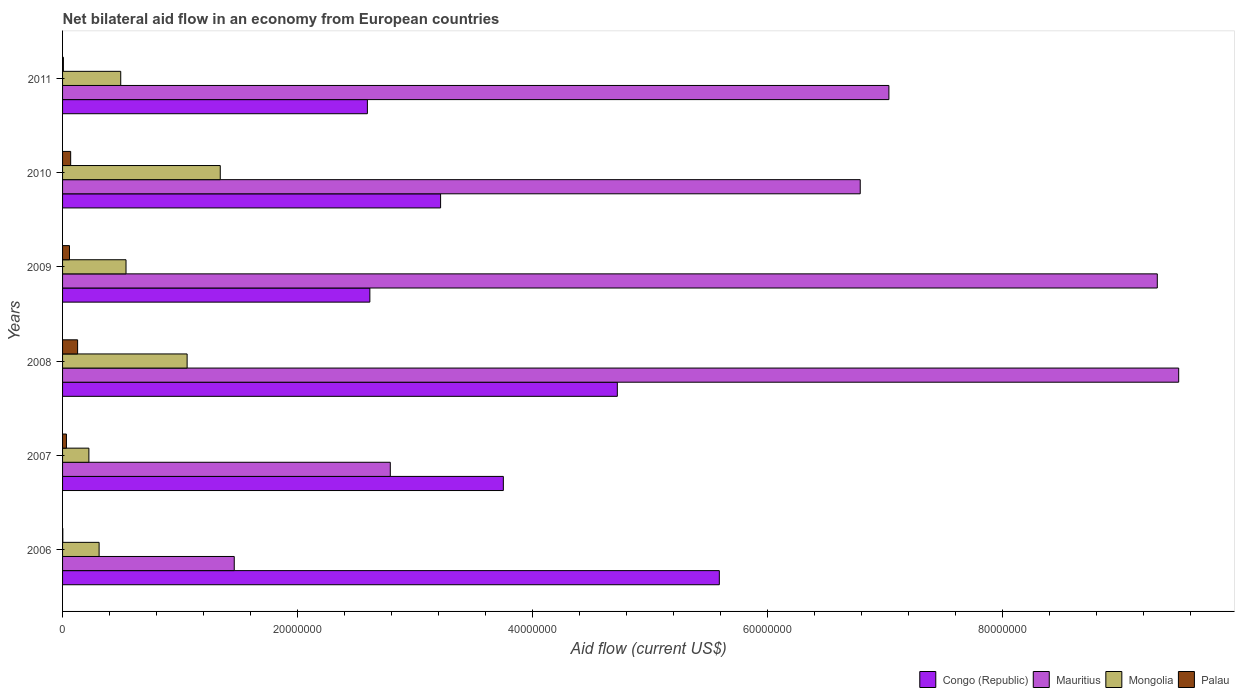How many different coloured bars are there?
Offer a very short reply. 4. How many groups of bars are there?
Your answer should be compact. 6. How many bars are there on the 6th tick from the bottom?
Make the answer very short. 4. What is the label of the 1st group of bars from the top?
Make the answer very short. 2011. What is the net bilateral aid flow in Mongolia in 2007?
Provide a succinct answer. 2.24e+06. Across all years, what is the maximum net bilateral aid flow in Palau?
Your response must be concise. 1.28e+06. In which year was the net bilateral aid flow in Congo (Republic) maximum?
Give a very brief answer. 2006. What is the total net bilateral aid flow in Palau in the graph?
Make the answer very short. 2.98e+06. What is the difference between the net bilateral aid flow in Palau in 2007 and that in 2008?
Your answer should be compact. -9.50e+05. What is the difference between the net bilateral aid flow in Mongolia in 2006 and the net bilateral aid flow in Palau in 2008?
Make the answer very short. 1.83e+06. What is the average net bilateral aid flow in Mauritius per year?
Your answer should be compact. 6.15e+07. In the year 2006, what is the difference between the net bilateral aid flow in Mauritius and net bilateral aid flow in Congo (Republic)?
Ensure brevity in your answer.  -4.13e+07. What is the ratio of the net bilateral aid flow in Congo (Republic) in 2008 to that in 2010?
Make the answer very short. 1.47. Is the difference between the net bilateral aid flow in Mauritius in 2006 and 2009 greater than the difference between the net bilateral aid flow in Congo (Republic) in 2006 and 2009?
Offer a terse response. No. What is the difference between the highest and the second highest net bilateral aid flow in Mauritius?
Offer a terse response. 1.82e+06. What is the difference between the highest and the lowest net bilateral aid flow in Congo (Republic)?
Offer a very short reply. 3.00e+07. Is the sum of the net bilateral aid flow in Palau in 2008 and 2009 greater than the maximum net bilateral aid flow in Congo (Republic) across all years?
Keep it short and to the point. No. What does the 2nd bar from the top in 2006 represents?
Ensure brevity in your answer.  Mongolia. What does the 2nd bar from the bottom in 2009 represents?
Keep it short and to the point. Mauritius. How many bars are there?
Provide a succinct answer. 24. Are all the bars in the graph horizontal?
Keep it short and to the point. Yes. How many years are there in the graph?
Offer a terse response. 6. What is the difference between two consecutive major ticks on the X-axis?
Ensure brevity in your answer.  2.00e+07. Does the graph contain any zero values?
Provide a succinct answer. No. Does the graph contain grids?
Your answer should be compact. No. How many legend labels are there?
Give a very brief answer. 4. What is the title of the graph?
Give a very brief answer. Net bilateral aid flow in an economy from European countries. What is the label or title of the Y-axis?
Provide a short and direct response. Years. What is the Aid flow (current US$) of Congo (Republic) in 2006?
Ensure brevity in your answer.  5.59e+07. What is the Aid flow (current US$) in Mauritius in 2006?
Offer a terse response. 1.46e+07. What is the Aid flow (current US$) of Mongolia in 2006?
Offer a terse response. 3.11e+06. What is the Aid flow (current US$) of Congo (Republic) in 2007?
Keep it short and to the point. 3.75e+07. What is the Aid flow (current US$) in Mauritius in 2007?
Your answer should be compact. 2.79e+07. What is the Aid flow (current US$) of Mongolia in 2007?
Offer a terse response. 2.24e+06. What is the Aid flow (current US$) in Palau in 2007?
Make the answer very short. 3.30e+05. What is the Aid flow (current US$) of Congo (Republic) in 2008?
Offer a terse response. 4.72e+07. What is the Aid flow (current US$) in Mauritius in 2008?
Ensure brevity in your answer.  9.50e+07. What is the Aid flow (current US$) of Mongolia in 2008?
Your response must be concise. 1.06e+07. What is the Aid flow (current US$) of Palau in 2008?
Keep it short and to the point. 1.28e+06. What is the Aid flow (current US$) in Congo (Republic) in 2009?
Ensure brevity in your answer.  2.62e+07. What is the Aid flow (current US$) of Mauritius in 2009?
Ensure brevity in your answer.  9.32e+07. What is the Aid flow (current US$) of Mongolia in 2009?
Give a very brief answer. 5.40e+06. What is the Aid flow (current US$) of Palau in 2009?
Your answer should be very brief. 5.90e+05. What is the Aid flow (current US$) of Congo (Republic) in 2010?
Give a very brief answer. 3.22e+07. What is the Aid flow (current US$) in Mauritius in 2010?
Give a very brief answer. 6.79e+07. What is the Aid flow (current US$) of Mongolia in 2010?
Provide a succinct answer. 1.34e+07. What is the Aid flow (current US$) of Palau in 2010?
Ensure brevity in your answer.  6.90e+05. What is the Aid flow (current US$) of Congo (Republic) in 2011?
Ensure brevity in your answer.  2.59e+07. What is the Aid flow (current US$) of Mauritius in 2011?
Make the answer very short. 7.03e+07. What is the Aid flow (current US$) in Mongolia in 2011?
Provide a succinct answer. 4.95e+06. Across all years, what is the maximum Aid flow (current US$) of Congo (Republic)?
Provide a succinct answer. 5.59e+07. Across all years, what is the maximum Aid flow (current US$) of Mauritius?
Your answer should be compact. 9.50e+07. Across all years, what is the maximum Aid flow (current US$) of Mongolia?
Offer a terse response. 1.34e+07. Across all years, what is the maximum Aid flow (current US$) in Palau?
Provide a succinct answer. 1.28e+06. Across all years, what is the minimum Aid flow (current US$) of Congo (Republic)?
Give a very brief answer. 2.59e+07. Across all years, what is the minimum Aid flow (current US$) in Mauritius?
Your answer should be compact. 1.46e+07. Across all years, what is the minimum Aid flow (current US$) of Mongolia?
Your answer should be very brief. 2.24e+06. What is the total Aid flow (current US$) of Congo (Republic) in the graph?
Give a very brief answer. 2.25e+08. What is the total Aid flow (current US$) of Mauritius in the graph?
Offer a very short reply. 3.69e+08. What is the total Aid flow (current US$) in Mongolia in the graph?
Give a very brief answer. 3.97e+07. What is the total Aid flow (current US$) in Palau in the graph?
Make the answer very short. 2.98e+06. What is the difference between the Aid flow (current US$) in Congo (Republic) in 2006 and that in 2007?
Make the answer very short. 1.84e+07. What is the difference between the Aid flow (current US$) in Mauritius in 2006 and that in 2007?
Your answer should be compact. -1.33e+07. What is the difference between the Aid flow (current US$) in Mongolia in 2006 and that in 2007?
Provide a short and direct response. 8.70e+05. What is the difference between the Aid flow (current US$) of Palau in 2006 and that in 2007?
Offer a terse response. -3.10e+05. What is the difference between the Aid flow (current US$) in Congo (Republic) in 2006 and that in 2008?
Provide a succinct answer. 8.68e+06. What is the difference between the Aid flow (current US$) in Mauritius in 2006 and that in 2008?
Give a very brief answer. -8.04e+07. What is the difference between the Aid flow (current US$) in Mongolia in 2006 and that in 2008?
Offer a very short reply. -7.49e+06. What is the difference between the Aid flow (current US$) in Palau in 2006 and that in 2008?
Offer a very short reply. -1.26e+06. What is the difference between the Aid flow (current US$) in Congo (Republic) in 2006 and that in 2009?
Provide a short and direct response. 2.97e+07. What is the difference between the Aid flow (current US$) in Mauritius in 2006 and that in 2009?
Provide a succinct answer. -7.86e+07. What is the difference between the Aid flow (current US$) in Mongolia in 2006 and that in 2009?
Give a very brief answer. -2.29e+06. What is the difference between the Aid flow (current US$) of Palau in 2006 and that in 2009?
Your answer should be very brief. -5.70e+05. What is the difference between the Aid flow (current US$) in Congo (Republic) in 2006 and that in 2010?
Provide a short and direct response. 2.37e+07. What is the difference between the Aid flow (current US$) in Mauritius in 2006 and that in 2010?
Ensure brevity in your answer.  -5.33e+07. What is the difference between the Aid flow (current US$) in Mongolia in 2006 and that in 2010?
Offer a very short reply. -1.03e+07. What is the difference between the Aid flow (current US$) in Palau in 2006 and that in 2010?
Provide a succinct answer. -6.70e+05. What is the difference between the Aid flow (current US$) in Congo (Republic) in 2006 and that in 2011?
Keep it short and to the point. 3.00e+07. What is the difference between the Aid flow (current US$) of Mauritius in 2006 and that in 2011?
Your answer should be compact. -5.57e+07. What is the difference between the Aid flow (current US$) in Mongolia in 2006 and that in 2011?
Ensure brevity in your answer.  -1.84e+06. What is the difference between the Aid flow (current US$) of Palau in 2006 and that in 2011?
Keep it short and to the point. -5.00e+04. What is the difference between the Aid flow (current US$) in Congo (Republic) in 2007 and that in 2008?
Offer a terse response. -9.70e+06. What is the difference between the Aid flow (current US$) of Mauritius in 2007 and that in 2008?
Your answer should be compact. -6.71e+07. What is the difference between the Aid flow (current US$) of Mongolia in 2007 and that in 2008?
Ensure brevity in your answer.  -8.36e+06. What is the difference between the Aid flow (current US$) of Palau in 2007 and that in 2008?
Offer a terse response. -9.50e+05. What is the difference between the Aid flow (current US$) of Congo (Republic) in 2007 and that in 2009?
Ensure brevity in your answer.  1.14e+07. What is the difference between the Aid flow (current US$) in Mauritius in 2007 and that in 2009?
Provide a succinct answer. -6.53e+07. What is the difference between the Aid flow (current US$) in Mongolia in 2007 and that in 2009?
Offer a terse response. -3.16e+06. What is the difference between the Aid flow (current US$) in Congo (Republic) in 2007 and that in 2010?
Your response must be concise. 5.34e+06. What is the difference between the Aid flow (current US$) of Mauritius in 2007 and that in 2010?
Your answer should be very brief. -4.00e+07. What is the difference between the Aid flow (current US$) of Mongolia in 2007 and that in 2010?
Your answer should be compact. -1.12e+07. What is the difference between the Aid flow (current US$) of Palau in 2007 and that in 2010?
Provide a short and direct response. -3.60e+05. What is the difference between the Aid flow (current US$) in Congo (Republic) in 2007 and that in 2011?
Make the answer very short. 1.16e+07. What is the difference between the Aid flow (current US$) in Mauritius in 2007 and that in 2011?
Provide a succinct answer. -4.24e+07. What is the difference between the Aid flow (current US$) in Mongolia in 2007 and that in 2011?
Your answer should be compact. -2.71e+06. What is the difference between the Aid flow (current US$) of Congo (Republic) in 2008 and that in 2009?
Keep it short and to the point. 2.11e+07. What is the difference between the Aid flow (current US$) in Mauritius in 2008 and that in 2009?
Give a very brief answer. 1.82e+06. What is the difference between the Aid flow (current US$) in Mongolia in 2008 and that in 2009?
Ensure brevity in your answer.  5.20e+06. What is the difference between the Aid flow (current US$) in Palau in 2008 and that in 2009?
Your answer should be compact. 6.90e+05. What is the difference between the Aid flow (current US$) of Congo (Republic) in 2008 and that in 2010?
Give a very brief answer. 1.50e+07. What is the difference between the Aid flow (current US$) of Mauritius in 2008 and that in 2010?
Ensure brevity in your answer.  2.71e+07. What is the difference between the Aid flow (current US$) of Mongolia in 2008 and that in 2010?
Provide a succinct answer. -2.82e+06. What is the difference between the Aid flow (current US$) of Palau in 2008 and that in 2010?
Your answer should be very brief. 5.90e+05. What is the difference between the Aid flow (current US$) of Congo (Republic) in 2008 and that in 2011?
Offer a very short reply. 2.13e+07. What is the difference between the Aid flow (current US$) in Mauritius in 2008 and that in 2011?
Your answer should be compact. 2.47e+07. What is the difference between the Aid flow (current US$) in Mongolia in 2008 and that in 2011?
Make the answer very short. 5.65e+06. What is the difference between the Aid flow (current US$) in Palau in 2008 and that in 2011?
Give a very brief answer. 1.21e+06. What is the difference between the Aid flow (current US$) in Congo (Republic) in 2009 and that in 2010?
Ensure brevity in your answer.  -6.02e+06. What is the difference between the Aid flow (current US$) of Mauritius in 2009 and that in 2010?
Keep it short and to the point. 2.53e+07. What is the difference between the Aid flow (current US$) in Mongolia in 2009 and that in 2010?
Offer a very short reply. -8.02e+06. What is the difference between the Aid flow (current US$) of Palau in 2009 and that in 2010?
Offer a very short reply. -1.00e+05. What is the difference between the Aid flow (current US$) in Mauritius in 2009 and that in 2011?
Give a very brief answer. 2.28e+07. What is the difference between the Aid flow (current US$) in Palau in 2009 and that in 2011?
Provide a succinct answer. 5.20e+05. What is the difference between the Aid flow (current US$) in Congo (Republic) in 2010 and that in 2011?
Give a very brief answer. 6.23e+06. What is the difference between the Aid flow (current US$) of Mauritius in 2010 and that in 2011?
Provide a short and direct response. -2.44e+06. What is the difference between the Aid flow (current US$) of Mongolia in 2010 and that in 2011?
Offer a very short reply. 8.47e+06. What is the difference between the Aid flow (current US$) in Palau in 2010 and that in 2011?
Offer a terse response. 6.20e+05. What is the difference between the Aid flow (current US$) in Congo (Republic) in 2006 and the Aid flow (current US$) in Mauritius in 2007?
Offer a terse response. 2.80e+07. What is the difference between the Aid flow (current US$) of Congo (Republic) in 2006 and the Aid flow (current US$) of Mongolia in 2007?
Give a very brief answer. 5.36e+07. What is the difference between the Aid flow (current US$) in Congo (Republic) in 2006 and the Aid flow (current US$) in Palau in 2007?
Your response must be concise. 5.56e+07. What is the difference between the Aid flow (current US$) of Mauritius in 2006 and the Aid flow (current US$) of Mongolia in 2007?
Your answer should be very brief. 1.24e+07. What is the difference between the Aid flow (current US$) of Mauritius in 2006 and the Aid flow (current US$) of Palau in 2007?
Keep it short and to the point. 1.43e+07. What is the difference between the Aid flow (current US$) of Mongolia in 2006 and the Aid flow (current US$) of Palau in 2007?
Provide a succinct answer. 2.78e+06. What is the difference between the Aid flow (current US$) in Congo (Republic) in 2006 and the Aid flow (current US$) in Mauritius in 2008?
Offer a terse response. -3.91e+07. What is the difference between the Aid flow (current US$) in Congo (Republic) in 2006 and the Aid flow (current US$) in Mongolia in 2008?
Your answer should be very brief. 4.53e+07. What is the difference between the Aid flow (current US$) in Congo (Republic) in 2006 and the Aid flow (current US$) in Palau in 2008?
Ensure brevity in your answer.  5.46e+07. What is the difference between the Aid flow (current US$) of Mauritius in 2006 and the Aid flow (current US$) of Mongolia in 2008?
Provide a succinct answer. 4.01e+06. What is the difference between the Aid flow (current US$) in Mauritius in 2006 and the Aid flow (current US$) in Palau in 2008?
Your answer should be very brief. 1.33e+07. What is the difference between the Aid flow (current US$) in Mongolia in 2006 and the Aid flow (current US$) in Palau in 2008?
Your answer should be compact. 1.83e+06. What is the difference between the Aid flow (current US$) of Congo (Republic) in 2006 and the Aid flow (current US$) of Mauritius in 2009?
Offer a very short reply. -3.73e+07. What is the difference between the Aid flow (current US$) of Congo (Republic) in 2006 and the Aid flow (current US$) of Mongolia in 2009?
Give a very brief answer. 5.05e+07. What is the difference between the Aid flow (current US$) in Congo (Republic) in 2006 and the Aid flow (current US$) in Palau in 2009?
Ensure brevity in your answer.  5.53e+07. What is the difference between the Aid flow (current US$) in Mauritius in 2006 and the Aid flow (current US$) in Mongolia in 2009?
Give a very brief answer. 9.21e+06. What is the difference between the Aid flow (current US$) in Mauritius in 2006 and the Aid flow (current US$) in Palau in 2009?
Offer a terse response. 1.40e+07. What is the difference between the Aid flow (current US$) of Mongolia in 2006 and the Aid flow (current US$) of Palau in 2009?
Your answer should be very brief. 2.52e+06. What is the difference between the Aid flow (current US$) of Congo (Republic) in 2006 and the Aid flow (current US$) of Mauritius in 2010?
Keep it short and to the point. -1.20e+07. What is the difference between the Aid flow (current US$) of Congo (Republic) in 2006 and the Aid flow (current US$) of Mongolia in 2010?
Give a very brief answer. 4.25e+07. What is the difference between the Aid flow (current US$) in Congo (Republic) in 2006 and the Aid flow (current US$) in Palau in 2010?
Provide a short and direct response. 5.52e+07. What is the difference between the Aid flow (current US$) of Mauritius in 2006 and the Aid flow (current US$) of Mongolia in 2010?
Give a very brief answer. 1.19e+06. What is the difference between the Aid flow (current US$) in Mauritius in 2006 and the Aid flow (current US$) in Palau in 2010?
Ensure brevity in your answer.  1.39e+07. What is the difference between the Aid flow (current US$) of Mongolia in 2006 and the Aid flow (current US$) of Palau in 2010?
Make the answer very short. 2.42e+06. What is the difference between the Aid flow (current US$) of Congo (Republic) in 2006 and the Aid flow (current US$) of Mauritius in 2011?
Offer a terse response. -1.44e+07. What is the difference between the Aid flow (current US$) in Congo (Republic) in 2006 and the Aid flow (current US$) in Mongolia in 2011?
Your answer should be very brief. 5.09e+07. What is the difference between the Aid flow (current US$) in Congo (Republic) in 2006 and the Aid flow (current US$) in Palau in 2011?
Provide a short and direct response. 5.58e+07. What is the difference between the Aid flow (current US$) of Mauritius in 2006 and the Aid flow (current US$) of Mongolia in 2011?
Offer a terse response. 9.66e+06. What is the difference between the Aid flow (current US$) of Mauritius in 2006 and the Aid flow (current US$) of Palau in 2011?
Provide a succinct answer. 1.45e+07. What is the difference between the Aid flow (current US$) of Mongolia in 2006 and the Aid flow (current US$) of Palau in 2011?
Make the answer very short. 3.04e+06. What is the difference between the Aid flow (current US$) of Congo (Republic) in 2007 and the Aid flow (current US$) of Mauritius in 2008?
Provide a short and direct response. -5.75e+07. What is the difference between the Aid flow (current US$) in Congo (Republic) in 2007 and the Aid flow (current US$) in Mongolia in 2008?
Offer a very short reply. 2.69e+07. What is the difference between the Aid flow (current US$) in Congo (Republic) in 2007 and the Aid flow (current US$) in Palau in 2008?
Make the answer very short. 3.62e+07. What is the difference between the Aid flow (current US$) in Mauritius in 2007 and the Aid flow (current US$) in Mongolia in 2008?
Provide a short and direct response. 1.73e+07. What is the difference between the Aid flow (current US$) in Mauritius in 2007 and the Aid flow (current US$) in Palau in 2008?
Offer a very short reply. 2.66e+07. What is the difference between the Aid flow (current US$) of Mongolia in 2007 and the Aid flow (current US$) of Palau in 2008?
Your answer should be compact. 9.60e+05. What is the difference between the Aid flow (current US$) in Congo (Republic) in 2007 and the Aid flow (current US$) in Mauritius in 2009?
Provide a succinct answer. -5.56e+07. What is the difference between the Aid flow (current US$) of Congo (Republic) in 2007 and the Aid flow (current US$) of Mongolia in 2009?
Your response must be concise. 3.21e+07. What is the difference between the Aid flow (current US$) of Congo (Republic) in 2007 and the Aid flow (current US$) of Palau in 2009?
Provide a succinct answer. 3.69e+07. What is the difference between the Aid flow (current US$) of Mauritius in 2007 and the Aid flow (current US$) of Mongolia in 2009?
Make the answer very short. 2.25e+07. What is the difference between the Aid flow (current US$) of Mauritius in 2007 and the Aid flow (current US$) of Palau in 2009?
Offer a very short reply. 2.73e+07. What is the difference between the Aid flow (current US$) of Mongolia in 2007 and the Aid flow (current US$) of Palau in 2009?
Offer a very short reply. 1.65e+06. What is the difference between the Aid flow (current US$) of Congo (Republic) in 2007 and the Aid flow (current US$) of Mauritius in 2010?
Your response must be concise. -3.04e+07. What is the difference between the Aid flow (current US$) in Congo (Republic) in 2007 and the Aid flow (current US$) in Mongolia in 2010?
Your answer should be very brief. 2.41e+07. What is the difference between the Aid flow (current US$) in Congo (Republic) in 2007 and the Aid flow (current US$) in Palau in 2010?
Make the answer very short. 3.68e+07. What is the difference between the Aid flow (current US$) of Mauritius in 2007 and the Aid flow (current US$) of Mongolia in 2010?
Provide a succinct answer. 1.45e+07. What is the difference between the Aid flow (current US$) in Mauritius in 2007 and the Aid flow (current US$) in Palau in 2010?
Keep it short and to the point. 2.72e+07. What is the difference between the Aid flow (current US$) of Mongolia in 2007 and the Aid flow (current US$) of Palau in 2010?
Your answer should be very brief. 1.55e+06. What is the difference between the Aid flow (current US$) of Congo (Republic) in 2007 and the Aid flow (current US$) of Mauritius in 2011?
Offer a very short reply. -3.28e+07. What is the difference between the Aid flow (current US$) in Congo (Republic) in 2007 and the Aid flow (current US$) in Mongolia in 2011?
Make the answer very short. 3.26e+07. What is the difference between the Aid flow (current US$) of Congo (Republic) in 2007 and the Aid flow (current US$) of Palau in 2011?
Offer a very short reply. 3.74e+07. What is the difference between the Aid flow (current US$) of Mauritius in 2007 and the Aid flow (current US$) of Mongolia in 2011?
Offer a very short reply. 2.29e+07. What is the difference between the Aid flow (current US$) in Mauritius in 2007 and the Aid flow (current US$) in Palau in 2011?
Your response must be concise. 2.78e+07. What is the difference between the Aid flow (current US$) of Mongolia in 2007 and the Aid flow (current US$) of Palau in 2011?
Offer a very short reply. 2.17e+06. What is the difference between the Aid flow (current US$) in Congo (Republic) in 2008 and the Aid flow (current US$) in Mauritius in 2009?
Keep it short and to the point. -4.60e+07. What is the difference between the Aid flow (current US$) of Congo (Republic) in 2008 and the Aid flow (current US$) of Mongolia in 2009?
Provide a succinct answer. 4.18e+07. What is the difference between the Aid flow (current US$) in Congo (Republic) in 2008 and the Aid flow (current US$) in Palau in 2009?
Keep it short and to the point. 4.66e+07. What is the difference between the Aid flow (current US$) of Mauritius in 2008 and the Aid flow (current US$) of Mongolia in 2009?
Make the answer very short. 8.96e+07. What is the difference between the Aid flow (current US$) of Mauritius in 2008 and the Aid flow (current US$) of Palau in 2009?
Your answer should be very brief. 9.44e+07. What is the difference between the Aid flow (current US$) in Mongolia in 2008 and the Aid flow (current US$) in Palau in 2009?
Provide a short and direct response. 1.00e+07. What is the difference between the Aid flow (current US$) in Congo (Republic) in 2008 and the Aid flow (current US$) in Mauritius in 2010?
Provide a short and direct response. -2.07e+07. What is the difference between the Aid flow (current US$) in Congo (Republic) in 2008 and the Aid flow (current US$) in Mongolia in 2010?
Your answer should be compact. 3.38e+07. What is the difference between the Aid flow (current US$) in Congo (Republic) in 2008 and the Aid flow (current US$) in Palau in 2010?
Provide a short and direct response. 4.65e+07. What is the difference between the Aid flow (current US$) in Mauritius in 2008 and the Aid flow (current US$) in Mongolia in 2010?
Give a very brief answer. 8.16e+07. What is the difference between the Aid flow (current US$) of Mauritius in 2008 and the Aid flow (current US$) of Palau in 2010?
Provide a short and direct response. 9.43e+07. What is the difference between the Aid flow (current US$) of Mongolia in 2008 and the Aid flow (current US$) of Palau in 2010?
Provide a succinct answer. 9.91e+06. What is the difference between the Aid flow (current US$) in Congo (Republic) in 2008 and the Aid flow (current US$) in Mauritius in 2011?
Offer a very short reply. -2.31e+07. What is the difference between the Aid flow (current US$) of Congo (Republic) in 2008 and the Aid flow (current US$) of Mongolia in 2011?
Provide a succinct answer. 4.23e+07. What is the difference between the Aid flow (current US$) of Congo (Republic) in 2008 and the Aid flow (current US$) of Palau in 2011?
Ensure brevity in your answer.  4.71e+07. What is the difference between the Aid flow (current US$) of Mauritius in 2008 and the Aid flow (current US$) of Mongolia in 2011?
Keep it short and to the point. 9.00e+07. What is the difference between the Aid flow (current US$) in Mauritius in 2008 and the Aid flow (current US$) in Palau in 2011?
Ensure brevity in your answer.  9.49e+07. What is the difference between the Aid flow (current US$) in Mongolia in 2008 and the Aid flow (current US$) in Palau in 2011?
Provide a short and direct response. 1.05e+07. What is the difference between the Aid flow (current US$) in Congo (Republic) in 2009 and the Aid flow (current US$) in Mauritius in 2010?
Your answer should be very brief. -4.17e+07. What is the difference between the Aid flow (current US$) of Congo (Republic) in 2009 and the Aid flow (current US$) of Mongolia in 2010?
Your answer should be compact. 1.27e+07. What is the difference between the Aid flow (current US$) of Congo (Republic) in 2009 and the Aid flow (current US$) of Palau in 2010?
Your answer should be very brief. 2.55e+07. What is the difference between the Aid flow (current US$) of Mauritius in 2009 and the Aid flow (current US$) of Mongolia in 2010?
Give a very brief answer. 7.97e+07. What is the difference between the Aid flow (current US$) in Mauritius in 2009 and the Aid flow (current US$) in Palau in 2010?
Make the answer very short. 9.25e+07. What is the difference between the Aid flow (current US$) in Mongolia in 2009 and the Aid flow (current US$) in Palau in 2010?
Give a very brief answer. 4.71e+06. What is the difference between the Aid flow (current US$) in Congo (Republic) in 2009 and the Aid flow (current US$) in Mauritius in 2011?
Your response must be concise. -4.42e+07. What is the difference between the Aid flow (current US$) in Congo (Republic) in 2009 and the Aid flow (current US$) in Mongolia in 2011?
Give a very brief answer. 2.12e+07. What is the difference between the Aid flow (current US$) in Congo (Republic) in 2009 and the Aid flow (current US$) in Palau in 2011?
Offer a very short reply. 2.61e+07. What is the difference between the Aid flow (current US$) in Mauritius in 2009 and the Aid flow (current US$) in Mongolia in 2011?
Keep it short and to the point. 8.82e+07. What is the difference between the Aid flow (current US$) in Mauritius in 2009 and the Aid flow (current US$) in Palau in 2011?
Your answer should be compact. 9.31e+07. What is the difference between the Aid flow (current US$) in Mongolia in 2009 and the Aid flow (current US$) in Palau in 2011?
Offer a terse response. 5.33e+06. What is the difference between the Aid flow (current US$) of Congo (Republic) in 2010 and the Aid flow (current US$) of Mauritius in 2011?
Provide a short and direct response. -3.82e+07. What is the difference between the Aid flow (current US$) in Congo (Republic) in 2010 and the Aid flow (current US$) in Mongolia in 2011?
Make the answer very short. 2.72e+07. What is the difference between the Aid flow (current US$) in Congo (Republic) in 2010 and the Aid flow (current US$) in Palau in 2011?
Your answer should be compact. 3.21e+07. What is the difference between the Aid flow (current US$) of Mauritius in 2010 and the Aid flow (current US$) of Mongolia in 2011?
Provide a succinct answer. 6.29e+07. What is the difference between the Aid flow (current US$) in Mauritius in 2010 and the Aid flow (current US$) in Palau in 2011?
Offer a very short reply. 6.78e+07. What is the difference between the Aid flow (current US$) of Mongolia in 2010 and the Aid flow (current US$) of Palau in 2011?
Ensure brevity in your answer.  1.34e+07. What is the average Aid flow (current US$) in Congo (Republic) per year?
Your answer should be very brief. 3.75e+07. What is the average Aid flow (current US$) of Mauritius per year?
Provide a succinct answer. 6.15e+07. What is the average Aid flow (current US$) in Mongolia per year?
Provide a short and direct response. 6.62e+06. What is the average Aid flow (current US$) of Palau per year?
Give a very brief answer. 4.97e+05. In the year 2006, what is the difference between the Aid flow (current US$) of Congo (Republic) and Aid flow (current US$) of Mauritius?
Give a very brief answer. 4.13e+07. In the year 2006, what is the difference between the Aid flow (current US$) of Congo (Republic) and Aid flow (current US$) of Mongolia?
Give a very brief answer. 5.28e+07. In the year 2006, what is the difference between the Aid flow (current US$) in Congo (Republic) and Aid flow (current US$) in Palau?
Make the answer very short. 5.59e+07. In the year 2006, what is the difference between the Aid flow (current US$) in Mauritius and Aid flow (current US$) in Mongolia?
Offer a very short reply. 1.15e+07. In the year 2006, what is the difference between the Aid flow (current US$) of Mauritius and Aid flow (current US$) of Palau?
Ensure brevity in your answer.  1.46e+07. In the year 2006, what is the difference between the Aid flow (current US$) in Mongolia and Aid flow (current US$) in Palau?
Keep it short and to the point. 3.09e+06. In the year 2007, what is the difference between the Aid flow (current US$) in Congo (Republic) and Aid flow (current US$) in Mauritius?
Provide a succinct answer. 9.62e+06. In the year 2007, what is the difference between the Aid flow (current US$) in Congo (Republic) and Aid flow (current US$) in Mongolia?
Your response must be concise. 3.53e+07. In the year 2007, what is the difference between the Aid flow (current US$) of Congo (Republic) and Aid flow (current US$) of Palau?
Provide a succinct answer. 3.72e+07. In the year 2007, what is the difference between the Aid flow (current US$) of Mauritius and Aid flow (current US$) of Mongolia?
Your answer should be very brief. 2.56e+07. In the year 2007, what is the difference between the Aid flow (current US$) of Mauritius and Aid flow (current US$) of Palau?
Your answer should be compact. 2.76e+07. In the year 2007, what is the difference between the Aid flow (current US$) of Mongolia and Aid flow (current US$) of Palau?
Your response must be concise. 1.91e+06. In the year 2008, what is the difference between the Aid flow (current US$) of Congo (Republic) and Aid flow (current US$) of Mauritius?
Offer a terse response. -4.78e+07. In the year 2008, what is the difference between the Aid flow (current US$) of Congo (Republic) and Aid flow (current US$) of Mongolia?
Keep it short and to the point. 3.66e+07. In the year 2008, what is the difference between the Aid flow (current US$) of Congo (Republic) and Aid flow (current US$) of Palau?
Offer a terse response. 4.59e+07. In the year 2008, what is the difference between the Aid flow (current US$) of Mauritius and Aid flow (current US$) of Mongolia?
Ensure brevity in your answer.  8.44e+07. In the year 2008, what is the difference between the Aid flow (current US$) in Mauritius and Aid flow (current US$) in Palau?
Offer a terse response. 9.37e+07. In the year 2008, what is the difference between the Aid flow (current US$) of Mongolia and Aid flow (current US$) of Palau?
Your answer should be compact. 9.32e+06. In the year 2009, what is the difference between the Aid flow (current US$) of Congo (Republic) and Aid flow (current US$) of Mauritius?
Offer a very short reply. -6.70e+07. In the year 2009, what is the difference between the Aid flow (current US$) in Congo (Republic) and Aid flow (current US$) in Mongolia?
Give a very brief answer. 2.08e+07. In the year 2009, what is the difference between the Aid flow (current US$) of Congo (Republic) and Aid flow (current US$) of Palau?
Offer a very short reply. 2.56e+07. In the year 2009, what is the difference between the Aid flow (current US$) in Mauritius and Aid flow (current US$) in Mongolia?
Offer a very short reply. 8.78e+07. In the year 2009, what is the difference between the Aid flow (current US$) of Mauritius and Aid flow (current US$) of Palau?
Your answer should be very brief. 9.26e+07. In the year 2009, what is the difference between the Aid flow (current US$) of Mongolia and Aid flow (current US$) of Palau?
Give a very brief answer. 4.81e+06. In the year 2010, what is the difference between the Aid flow (current US$) in Congo (Republic) and Aid flow (current US$) in Mauritius?
Your answer should be compact. -3.57e+07. In the year 2010, what is the difference between the Aid flow (current US$) of Congo (Republic) and Aid flow (current US$) of Mongolia?
Offer a very short reply. 1.88e+07. In the year 2010, what is the difference between the Aid flow (current US$) in Congo (Republic) and Aid flow (current US$) in Palau?
Your answer should be compact. 3.15e+07. In the year 2010, what is the difference between the Aid flow (current US$) of Mauritius and Aid flow (current US$) of Mongolia?
Provide a short and direct response. 5.45e+07. In the year 2010, what is the difference between the Aid flow (current US$) of Mauritius and Aid flow (current US$) of Palau?
Provide a succinct answer. 6.72e+07. In the year 2010, what is the difference between the Aid flow (current US$) in Mongolia and Aid flow (current US$) in Palau?
Provide a succinct answer. 1.27e+07. In the year 2011, what is the difference between the Aid flow (current US$) in Congo (Republic) and Aid flow (current US$) in Mauritius?
Your answer should be very brief. -4.44e+07. In the year 2011, what is the difference between the Aid flow (current US$) in Congo (Republic) and Aid flow (current US$) in Mongolia?
Your answer should be compact. 2.10e+07. In the year 2011, what is the difference between the Aid flow (current US$) in Congo (Republic) and Aid flow (current US$) in Palau?
Offer a very short reply. 2.59e+07. In the year 2011, what is the difference between the Aid flow (current US$) of Mauritius and Aid flow (current US$) of Mongolia?
Provide a short and direct response. 6.54e+07. In the year 2011, what is the difference between the Aid flow (current US$) of Mauritius and Aid flow (current US$) of Palau?
Give a very brief answer. 7.02e+07. In the year 2011, what is the difference between the Aid flow (current US$) of Mongolia and Aid flow (current US$) of Palau?
Ensure brevity in your answer.  4.88e+06. What is the ratio of the Aid flow (current US$) of Congo (Republic) in 2006 to that in 2007?
Ensure brevity in your answer.  1.49. What is the ratio of the Aid flow (current US$) in Mauritius in 2006 to that in 2007?
Your response must be concise. 0.52. What is the ratio of the Aid flow (current US$) in Mongolia in 2006 to that in 2007?
Your response must be concise. 1.39. What is the ratio of the Aid flow (current US$) of Palau in 2006 to that in 2007?
Your response must be concise. 0.06. What is the ratio of the Aid flow (current US$) in Congo (Republic) in 2006 to that in 2008?
Give a very brief answer. 1.18. What is the ratio of the Aid flow (current US$) of Mauritius in 2006 to that in 2008?
Ensure brevity in your answer.  0.15. What is the ratio of the Aid flow (current US$) in Mongolia in 2006 to that in 2008?
Your answer should be compact. 0.29. What is the ratio of the Aid flow (current US$) in Palau in 2006 to that in 2008?
Your response must be concise. 0.02. What is the ratio of the Aid flow (current US$) in Congo (Republic) in 2006 to that in 2009?
Provide a succinct answer. 2.14. What is the ratio of the Aid flow (current US$) in Mauritius in 2006 to that in 2009?
Keep it short and to the point. 0.16. What is the ratio of the Aid flow (current US$) of Mongolia in 2006 to that in 2009?
Provide a short and direct response. 0.58. What is the ratio of the Aid flow (current US$) in Palau in 2006 to that in 2009?
Your response must be concise. 0.03. What is the ratio of the Aid flow (current US$) of Congo (Republic) in 2006 to that in 2010?
Your answer should be very brief. 1.74. What is the ratio of the Aid flow (current US$) in Mauritius in 2006 to that in 2010?
Give a very brief answer. 0.22. What is the ratio of the Aid flow (current US$) in Mongolia in 2006 to that in 2010?
Make the answer very short. 0.23. What is the ratio of the Aid flow (current US$) in Palau in 2006 to that in 2010?
Make the answer very short. 0.03. What is the ratio of the Aid flow (current US$) in Congo (Republic) in 2006 to that in 2011?
Offer a terse response. 2.15. What is the ratio of the Aid flow (current US$) in Mauritius in 2006 to that in 2011?
Your response must be concise. 0.21. What is the ratio of the Aid flow (current US$) of Mongolia in 2006 to that in 2011?
Your answer should be compact. 0.63. What is the ratio of the Aid flow (current US$) of Palau in 2006 to that in 2011?
Offer a terse response. 0.29. What is the ratio of the Aid flow (current US$) in Congo (Republic) in 2007 to that in 2008?
Your response must be concise. 0.79. What is the ratio of the Aid flow (current US$) of Mauritius in 2007 to that in 2008?
Provide a short and direct response. 0.29. What is the ratio of the Aid flow (current US$) in Mongolia in 2007 to that in 2008?
Ensure brevity in your answer.  0.21. What is the ratio of the Aid flow (current US$) of Palau in 2007 to that in 2008?
Make the answer very short. 0.26. What is the ratio of the Aid flow (current US$) of Congo (Republic) in 2007 to that in 2009?
Give a very brief answer. 1.43. What is the ratio of the Aid flow (current US$) of Mauritius in 2007 to that in 2009?
Provide a succinct answer. 0.3. What is the ratio of the Aid flow (current US$) in Mongolia in 2007 to that in 2009?
Provide a short and direct response. 0.41. What is the ratio of the Aid flow (current US$) in Palau in 2007 to that in 2009?
Keep it short and to the point. 0.56. What is the ratio of the Aid flow (current US$) of Congo (Republic) in 2007 to that in 2010?
Offer a terse response. 1.17. What is the ratio of the Aid flow (current US$) in Mauritius in 2007 to that in 2010?
Your response must be concise. 0.41. What is the ratio of the Aid flow (current US$) in Mongolia in 2007 to that in 2010?
Provide a succinct answer. 0.17. What is the ratio of the Aid flow (current US$) in Palau in 2007 to that in 2010?
Offer a terse response. 0.48. What is the ratio of the Aid flow (current US$) in Congo (Republic) in 2007 to that in 2011?
Provide a succinct answer. 1.45. What is the ratio of the Aid flow (current US$) of Mauritius in 2007 to that in 2011?
Your response must be concise. 0.4. What is the ratio of the Aid flow (current US$) of Mongolia in 2007 to that in 2011?
Ensure brevity in your answer.  0.45. What is the ratio of the Aid flow (current US$) of Palau in 2007 to that in 2011?
Offer a terse response. 4.71. What is the ratio of the Aid flow (current US$) of Congo (Republic) in 2008 to that in 2009?
Your answer should be very brief. 1.81. What is the ratio of the Aid flow (current US$) of Mauritius in 2008 to that in 2009?
Give a very brief answer. 1.02. What is the ratio of the Aid flow (current US$) in Mongolia in 2008 to that in 2009?
Provide a succinct answer. 1.96. What is the ratio of the Aid flow (current US$) of Palau in 2008 to that in 2009?
Provide a short and direct response. 2.17. What is the ratio of the Aid flow (current US$) in Congo (Republic) in 2008 to that in 2010?
Your answer should be compact. 1.47. What is the ratio of the Aid flow (current US$) of Mauritius in 2008 to that in 2010?
Keep it short and to the point. 1.4. What is the ratio of the Aid flow (current US$) of Mongolia in 2008 to that in 2010?
Offer a terse response. 0.79. What is the ratio of the Aid flow (current US$) of Palau in 2008 to that in 2010?
Make the answer very short. 1.86. What is the ratio of the Aid flow (current US$) of Congo (Republic) in 2008 to that in 2011?
Make the answer very short. 1.82. What is the ratio of the Aid flow (current US$) in Mauritius in 2008 to that in 2011?
Provide a succinct answer. 1.35. What is the ratio of the Aid flow (current US$) of Mongolia in 2008 to that in 2011?
Your response must be concise. 2.14. What is the ratio of the Aid flow (current US$) of Palau in 2008 to that in 2011?
Give a very brief answer. 18.29. What is the ratio of the Aid flow (current US$) of Congo (Republic) in 2009 to that in 2010?
Provide a succinct answer. 0.81. What is the ratio of the Aid flow (current US$) in Mauritius in 2009 to that in 2010?
Ensure brevity in your answer.  1.37. What is the ratio of the Aid flow (current US$) of Mongolia in 2009 to that in 2010?
Your response must be concise. 0.4. What is the ratio of the Aid flow (current US$) in Palau in 2009 to that in 2010?
Your response must be concise. 0.86. What is the ratio of the Aid flow (current US$) in Mauritius in 2009 to that in 2011?
Provide a succinct answer. 1.32. What is the ratio of the Aid flow (current US$) in Mongolia in 2009 to that in 2011?
Your answer should be very brief. 1.09. What is the ratio of the Aid flow (current US$) of Palau in 2009 to that in 2011?
Make the answer very short. 8.43. What is the ratio of the Aid flow (current US$) in Congo (Republic) in 2010 to that in 2011?
Your response must be concise. 1.24. What is the ratio of the Aid flow (current US$) in Mauritius in 2010 to that in 2011?
Provide a short and direct response. 0.97. What is the ratio of the Aid flow (current US$) of Mongolia in 2010 to that in 2011?
Ensure brevity in your answer.  2.71. What is the ratio of the Aid flow (current US$) of Palau in 2010 to that in 2011?
Keep it short and to the point. 9.86. What is the difference between the highest and the second highest Aid flow (current US$) of Congo (Republic)?
Provide a short and direct response. 8.68e+06. What is the difference between the highest and the second highest Aid flow (current US$) of Mauritius?
Keep it short and to the point. 1.82e+06. What is the difference between the highest and the second highest Aid flow (current US$) of Mongolia?
Offer a terse response. 2.82e+06. What is the difference between the highest and the second highest Aid flow (current US$) of Palau?
Give a very brief answer. 5.90e+05. What is the difference between the highest and the lowest Aid flow (current US$) in Congo (Republic)?
Provide a succinct answer. 3.00e+07. What is the difference between the highest and the lowest Aid flow (current US$) in Mauritius?
Offer a very short reply. 8.04e+07. What is the difference between the highest and the lowest Aid flow (current US$) in Mongolia?
Make the answer very short. 1.12e+07. What is the difference between the highest and the lowest Aid flow (current US$) of Palau?
Give a very brief answer. 1.26e+06. 